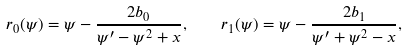<formula> <loc_0><loc_0><loc_500><loc_500>r _ { 0 } ( \psi ) = \psi - \frac { 2 b _ { 0 } } { \psi ^ { \prime } - \psi ^ { 2 } + x } , \quad r _ { 1 } ( \psi ) = \psi - \frac { 2 b _ { 1 } } { \psi ^ { \prime } + \psi ^ { 2 } - x } ,</formula> 